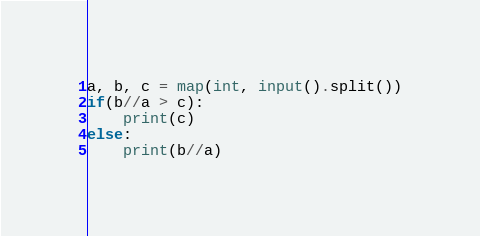Convert code to text. <code><loc_0><loc_0><loc_500><loc_500><_Python_>a, b, c = map(int, input().split())
if(b//a > c):
    print(c)
else:
    print(b//a)</code> 